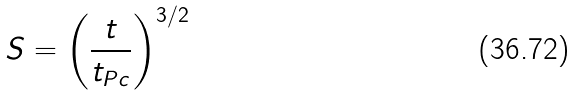<formula> <loc_0><loc_0><loc_500><loc_500>S = \left ( { { \frac { t } { { t _ { P c } } } } } \right ) ^ { 3 / 2 }</formula> 